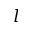Convert formula to latex. <formula><loc_0><loc_0><loc_500><loc_500>l</formula> 